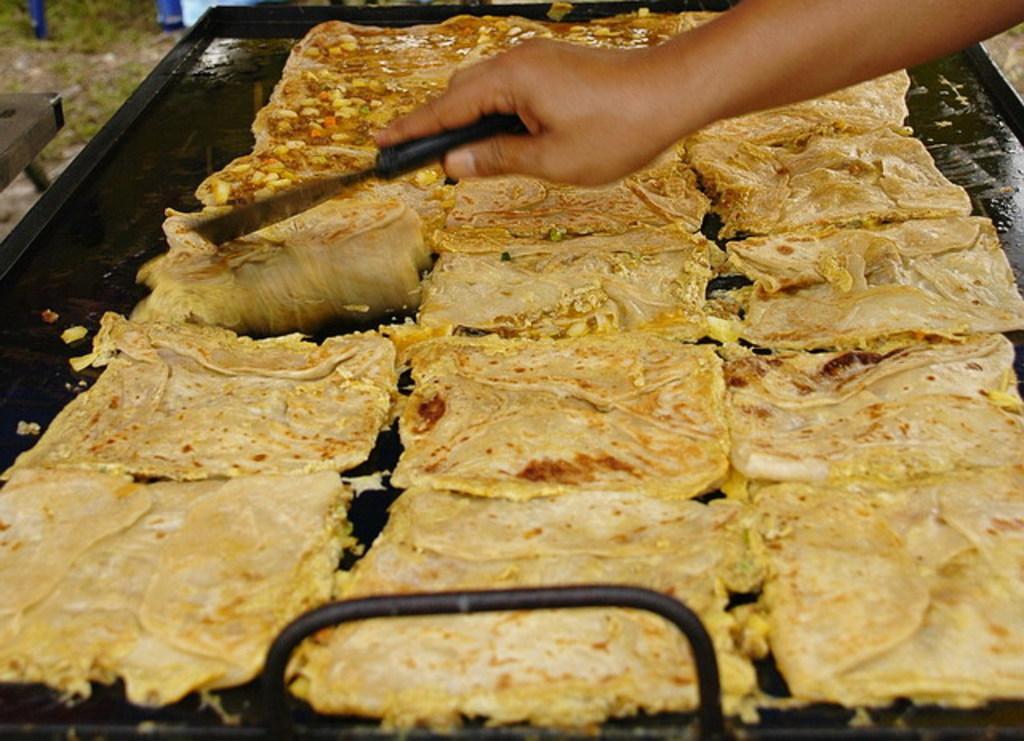Can you describe this image briefly? In this image at the bottom there is one tray and on the train, there are some food items. And there is one person who is holding a spatula, and he is doing something. 